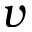Convert formula to latex. <formula><loc_0><loc_0><loc_500><loc_500>v</formula> 